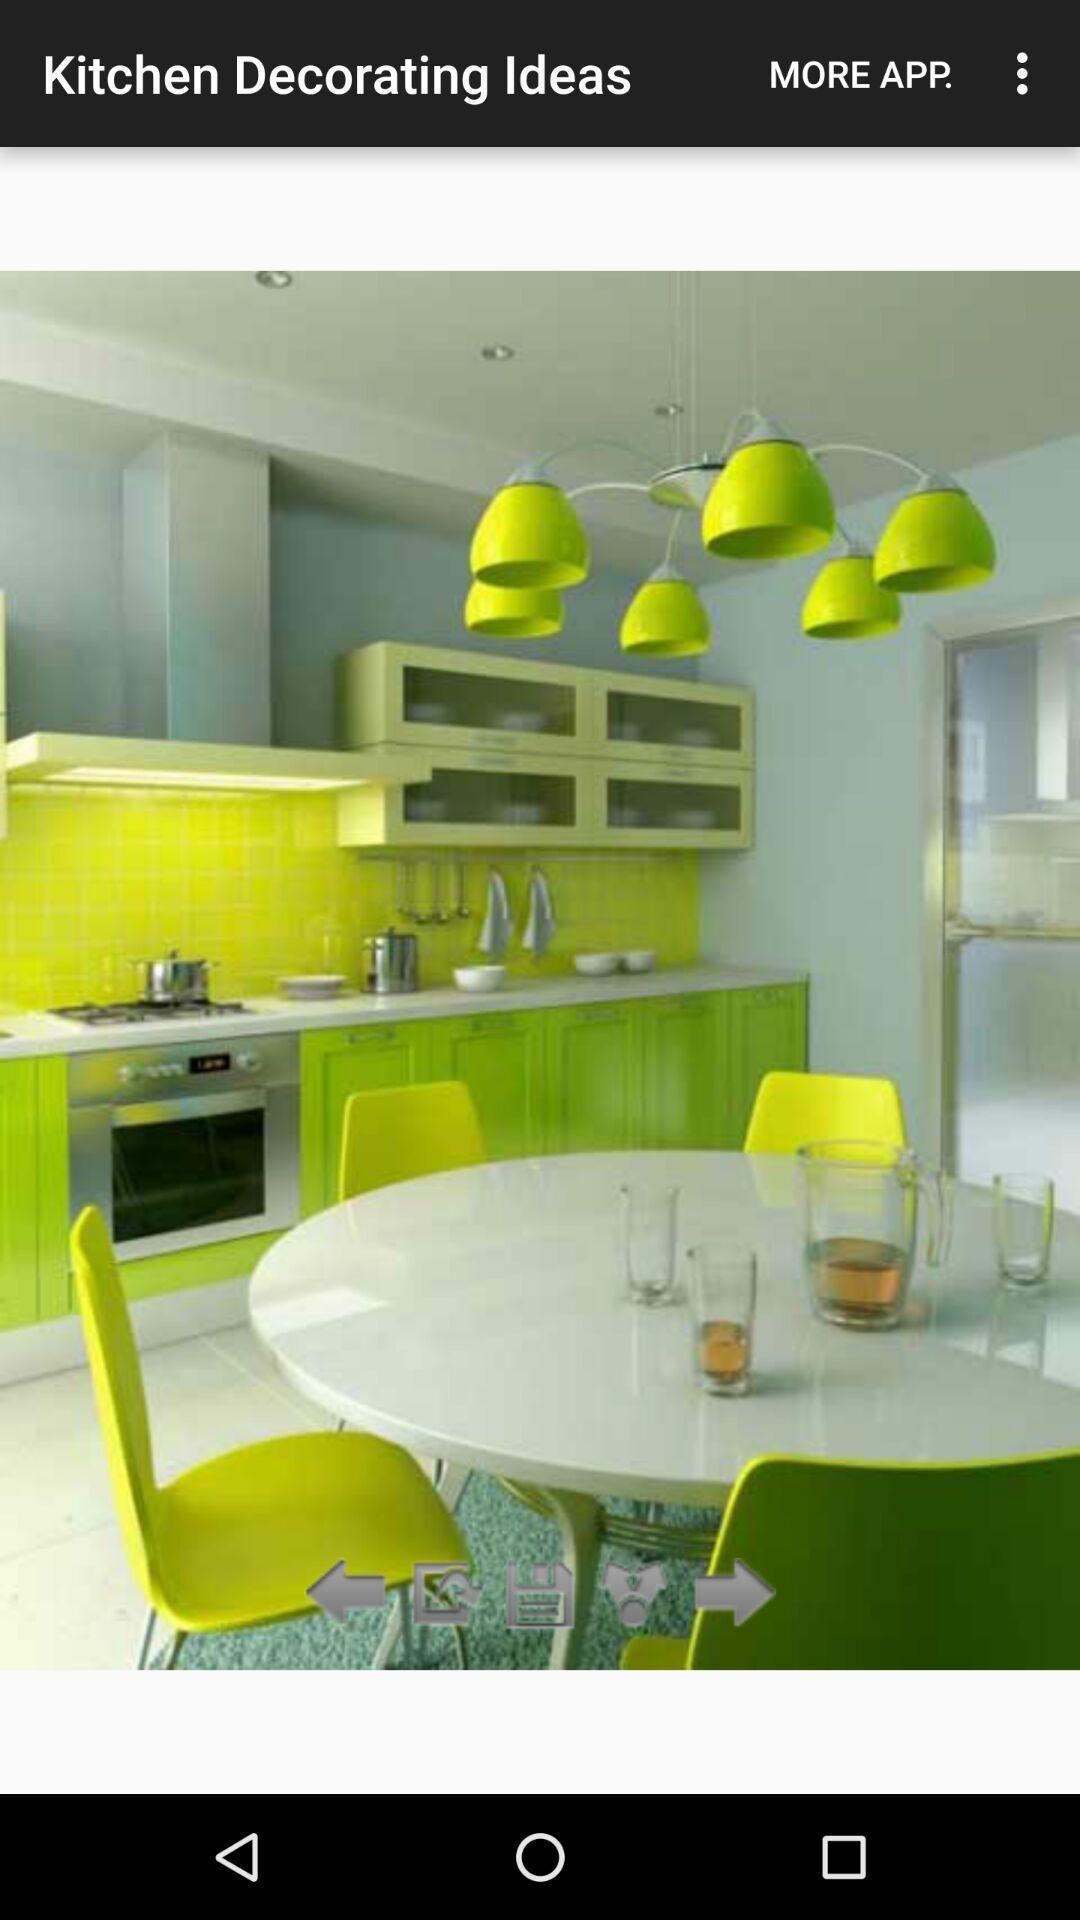Describe the visual elements of this screenshot. Screen displaying the image of kitchen decoration. 